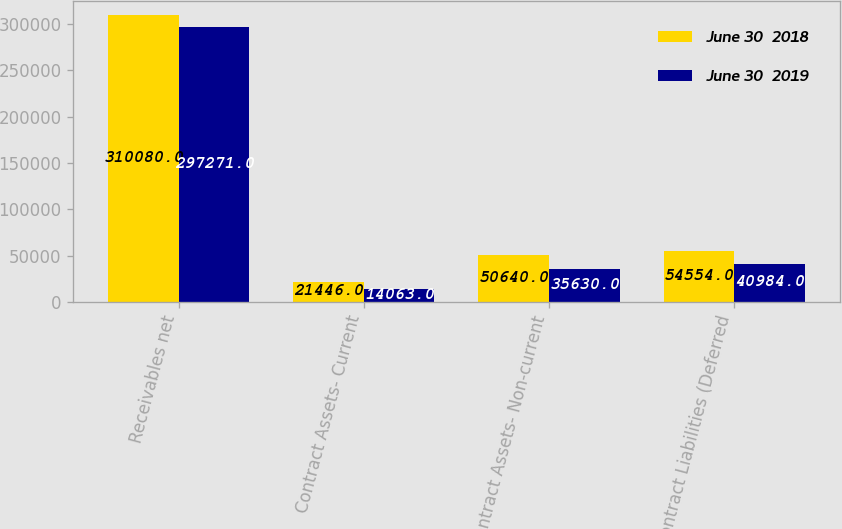Convert chart to OTSL. <chart><loc_0><loc_0><loc_500><loc_500><stacked_bar_chart><ecel><fcel>Receivables net<fcel>Contract Assets- Current<fcel>Contract Assets- Non-current<fcel>Contract Liabilities (Deferred<nl><fcel>June 30  2018<fcel>310080<fcel>21446<fcel>50640<fcel>54554<nl><fcel>June 30  2019<fcel>297271<fcel>14063<fcel>35630<fcel>40984<nl></chart> 